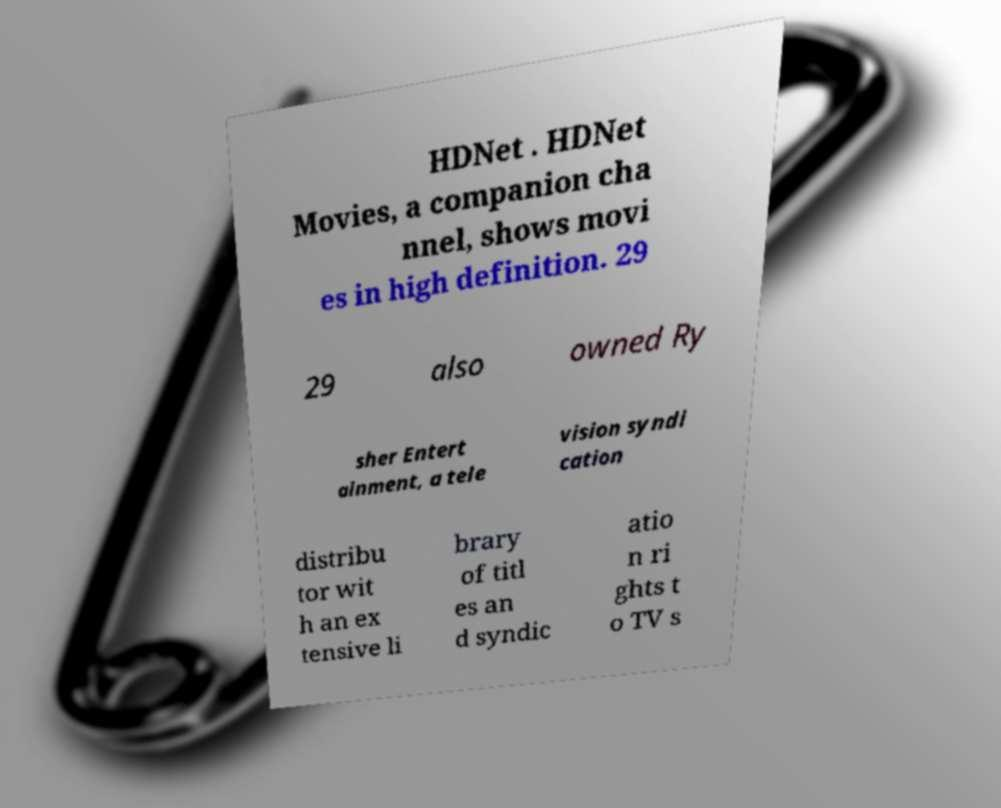Can you read and provide the text displayed in the image?This photo seems to have some interesting text. Can you extract and type it out for me? HDNet . HDNet Movies, a companion cha nnel, shows movi es in high definition. 29 29 also owned Ry sher Entert ainment, a tele vision syndi cation distribu tor wit h an ex tensive li brary of titl es an d syndic atio n ri ghts t o TV s 